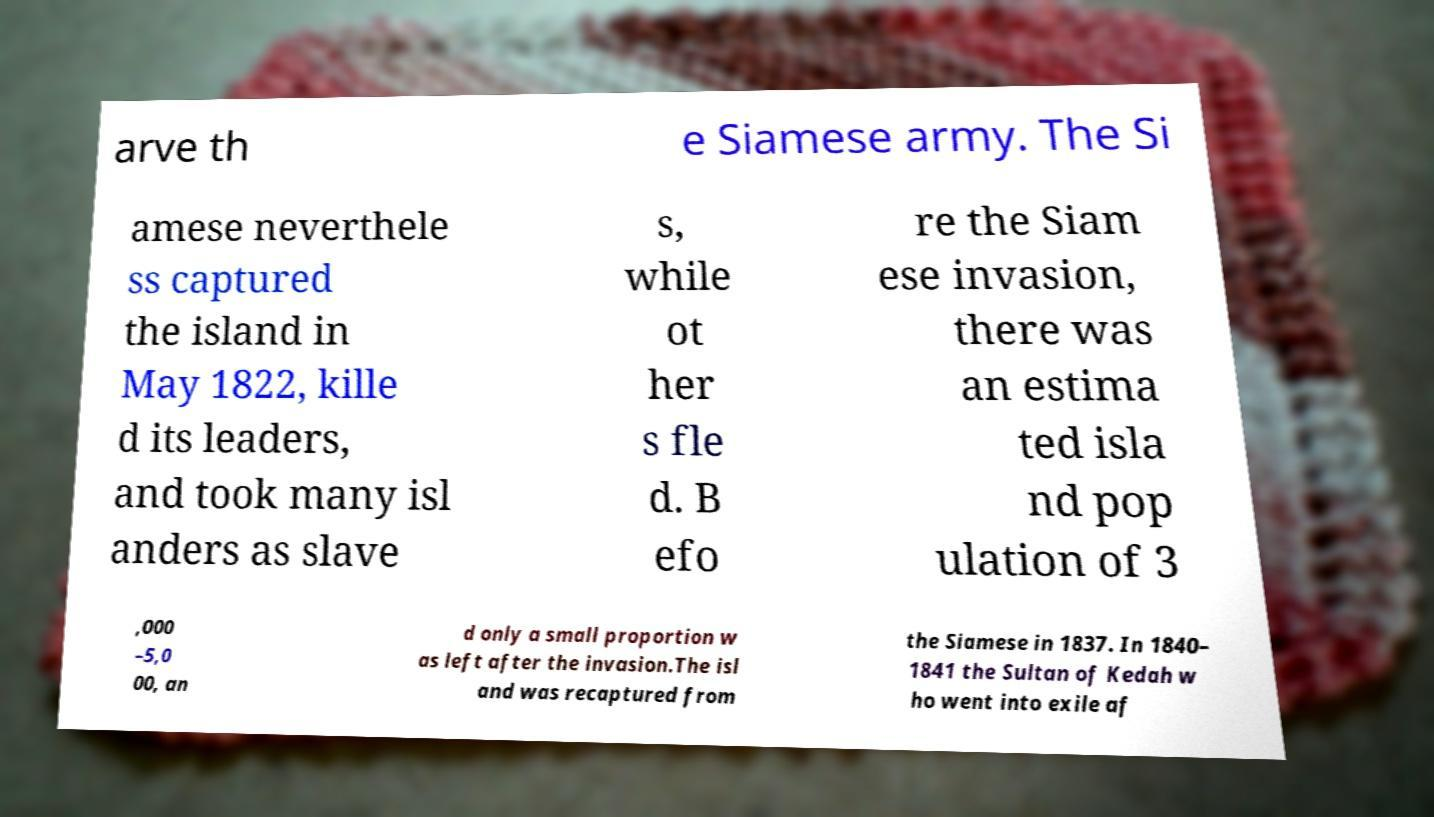Please read and relay the text visible in this image. What does it say? arve th e Siamese army. The Si amese neverthele ss captured the island in May 1822, kille d its leaders, and took many isl anders as slave s, while ot her s fle d. B efo re the Siam ese invasion, there was an estima ted isla nd pop ulation of 3 ,000 –5,0 00, an d only a small proportion w as left after the invasion.The isl and was recaptured from the Siamese in 1837. In 1840– 1841 the Sultan of Kedah w ho went into exile af 